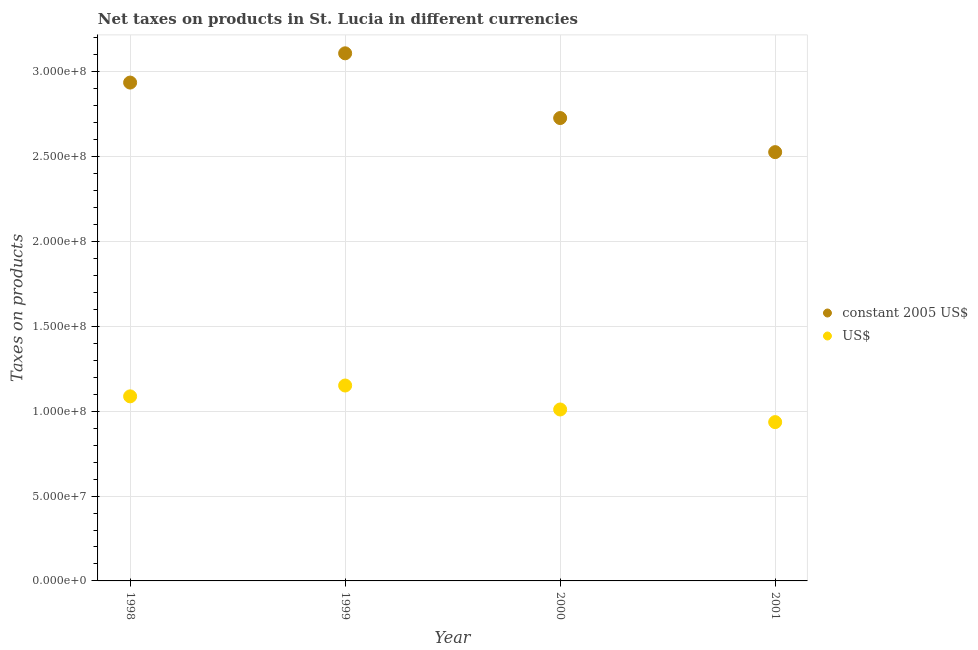What is the net taxes in us$ in 1999?
Ensure brevity in your answer.  1.15e+08. Across all years, what is the maximum net taxes in us$?
Offer a terse response. 1.15e+08. Across all years, what is the minimum net taxes in us$?
Your response must be concise. 9.36e+07. In which year was the net taxes in constant 2005 us$ maximum?
Keep it short and to the point. 1999. What is the total net taxes in constant 2005 us$ in the graph?
Offer a terse response. 1.13e+09. What is the difference between the net taxes in us$ in 1999 and that in 2001?
Offer a very short reply. 2.16e+07. What is the difference between the net taxes in constant 2005 us$ in 2001 and the net taxes in us$ in 2000?
Provide a short and direct response. 1.52e+08. What is the average net taxes in us$ per year?
Your response must be concise. 1.05e+08. In the year 2001, what is the difference between the net taxes in constant 2005 us$ and net taxes in us$?
Your answer should be very brief. 1.59e+08. In how many years, is the net taxes in us$ greater than 120000000 units?
Give a very brief answer. 0. What is the ratio of the net taxes in us$ in 1999 to that in 2000?
Provide a succinct answer. 1.14. Is the difference between the net taxes in constant 2005 us$ in 1998 and 1999 greater than the difference between the net taxes in us$ in 1998 and 1999?
Ensure brevity in your answer.  No. What is the difference between the highest and the second highest net taxes in us$?
Provide a succinct answer. 6.39e+06. What is the difference between the highest and the lowest net taxes in us$?
Your response must be concise. 2.16e+07. Is the sum of the net taxes in us$ in 1998 and 1999 greater than the maximum net taxes in constant 2005 us$ across all years?
Offer a very short reply. No. Is the net taxes in constant 2005 us$ strictly greater than the net taxes in us$ over the years?
Provide a short and direct response. Yes. How many years are there in the graph?
Provide a short and direct response. 4. Where does the legend appear in the graph?
Your answer should be compact. Center right. How many legend labels are there?
Offer a very short reply. 2. What is the title of the graph?
Your answer should be very brief. Net taxes on products in St. Lucia in different currencies. Does "Formally registered" appear as one of the legend labels in the graph?
Your answer should be very brief. No. What is the label or title of the Y-axis?
Offer a very short reply. Taxes on products. What is the Taxes on products in constant 2005 US$ in 1998?
Provide a succinct answer. 2.94e+08. What is the Taxes on products of US$ in 1998?
Your answer should be compact. 1.09e+08. What is the Taxes on products of constant 2005 US$ in 1999?
Your answer should be very brief. 3.11e+08. What is the Taxes on products of US$ in 1999?
Keep it short and to the point. 1.15e+08. What is the Taxes on products in constant 2005 US$ in 2000?
Provide a succinct answer. 2.73e+08. What is the Taxes on products in US$ in 2000?
Offer a terse response. 1.01e+08. What is the Taxes on products of constant 2005 US$ in 2001?
Make the answer very short. 2.53e+08. What is the Taxes on products of US$ in 2001?
Your response must be concise. 9.36e+07. Across all years, what is the maximum Taxes on products in constant 2005 US$?
Your answer should be very brief. 3.11e+08. Across all years, what is the maximum Taxes on products of US$?
Make the answer very short. 1.15e+08. Across all years, what is the minimum Taxes on products in constant 2005 US$?
Provide a succinct answer. 2.53e+08. Across all years, what is the minimum Taxes on products of US$?
Your answer should be compact. 9.36e+07. What is the total Taxes on products of constant 2005 US$ in the graph?
Your answer should be very brief. 1.13e+09. What is the total Taxes on products in US$ in the graph?
Offer a terse response. 4.18e+08. What is the difference between the Taxes on products of constant 2005 US$ in 1998 and that in 1999?
Your answer should be compact. -1.72e+07. What is the difference between the Taxes on products of US$ in 1998 and that in 1999?
Offer a terse response. -6.39e+06. What is the difference between the Taxes on products of constant 2005 US$ in 1998 and that in 2000?
Offer a very short reply. 2.09e+07. What is the difference between the Taxes on products of US$ in 1998 and that in 2000?
Offer a terse response. 7.74e+06. What is the difference between the Taxes on products in constant 2005 US$ in 1998 and that in 2001?
Your answer should be compact. 4.10e+07. What is the difference between the Taxes on products of US$ in 1998 and that in 2001?
Your answer should be compact. 1.52e+07. What is the difference between the Taxes on products of constant 2005 US$ in 1999 and that in 2000?
Provide a succinct answer. 3.81e+07. What is the difference between the Taxes on products in US$ in 1999 and that in 2000?
Offer a very short reply. 1.41e+07. What is the difference between the Taxes on products in constant 2005 US$ in 1999 and that in 2001?
Ensure brevity in your answer.  5.82e+07. What is the difference between the Taxes on products of US$ in 1999 and that in 2001?
Provide a short and direct response. 2.16e+07. What is the difference between the Taxes on products of constant 2005 US$ in 2000 and that in 2001?
Make the answer very short. 2.01e+07. What is the difference between the Taxes on products of US$ in 2000 and that in 2001?
Give a very brief answer. 7.44e+06. What is the difference between the Taxes on products in constant 2005 US$ in 1998 and the Taxes on products in US$ in 1999?
Offer a very short reply. 1.78e+08. What is the difference between the Taxes on products of constant 2005 US$ in 1998 and the Taxes on products of US$ in 2000?
Give a very brief answer. 1.93e+08. What is the difference between the Taxes on products of constant 2005 US$ in 1998 and the Taxes on products of US$ in 2001?
Your answer should be compact. 2.00e+08. What is the difference between the Taxes on products in constant 2005 US$ in 1999 and the Taxes on products in US$ in 2000?
Offer a very short reply. 2.10e+08. What is the difference between the Taxes on products of constant 2005 US$ in 1999 and the Taxes on products of US$ in 2001?
Provide a short and direct response. 2.17e+08. What is the difference between the Taxes on products in constant 2005 US$ in 2000 and the Taxes on products in US$ in 2001?
Your answer should be very brief. 1.79e+08. What is the average Taxes on products in constant 2005 US$ per year?
Provide a short and direct response. 2.82e+08. What is the average Taxes on products of US$ per year?
Your answer should be compact. 1.05e+08. In the year 1998, what is the difference between the Taxes on products in constant 2005 US$ and Taxes on products in US$?
Keep it short and to the point. 1.85e+08. In the year 1999, what is the difference between the Taxes on products in constant 2005 US$ and Taxes on products in US$?
Offer a very short reply. 1.96e+08. In the year 2000, what is the difference between the Taxes on products of constant 2005 US$ and Taxes on products of US$?
Ensure brevity in your answer.  1.72e+08. In the year 2001, what is the difference between the Taxes on products in constant 2005 US$ and Taxes on products in US$?
Offer a terse response. 1.59e+08. What is the ratio of the Taxes on products in constant 2005 US$ in 1998 to that in 1999?
Your answer should be very brief. 0.94. What is the ratio of the Taxes on products of US$ in 1998 to that in 1999?
Make the answer very short. 0.94. What is the ratio of the Taxes on products in constant 2005 US$ in 1998 to that in 2000?
Your response must be concise. 1.08. What is the ratio of the Taxes on products in US$ in 1998 to that in 2000?
Your response must be concise. 1.08. What is the ratio of the Taxes on products of constant 2005 US$ in 1998 to that in 2001?
Give a very brief answer. 1.16. What is the ratio of the Taxes on products in US$ in 1998 to that in 2001?
Give a very brief answer. 1.16. What is the ratio of the Taxes on products in constant 2005 US$ in 1999 to that in 2000?
Your answer should be very brief. 1.14. What is the ratio of the Taxes on products in US$ in 1999 to that in 2000?
Your answer should be very brief. 1.14. What is the ratio of the Taxes on products of constant 2005 US$ in 1999 to that in 2001?
Offer a very short reply. 1.23. What is the ratio of the Taxes on products of US$ in 1999 to that in 2001?
Give a very brief answer. 1.23. What is the ratio of the Taxes on products in constant 2005 US$ in 2000 to that in 2001?
Your response must be concise. 1.08. What is the ratio of the Taxes on products of US$ in 2000 to that in 2001?
Provide a short and direct response. 1.08. What is the difference between the highest and the second highest Taxes on products in constant 2005 US$?
Offer a very short reply. 1.72e+07. What is the difference between the highest and the second highest Taxes on products of US$?
Keep it short and to the point. 6.39e+06. What is the difference between the highest and the lowest Taxes on products of constant 2005 US$?
Your answer should be compact. 5.82e+07. What is the difference between the highest and the lowest Taxes on products in US$?
Provide a short and direct response. 2.16e+07. 